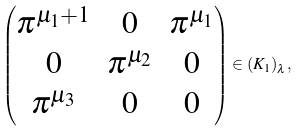Convert formula to latex. <formula><loc_0><loc_0><loc_500><loc_500>\begin{pmatrix} \pi ^ { \mu _ { 1 } + 1 } & 0 & \pi ^ { \mu _ { 1 } } \\ 0 & \pi ^ { \mu _ { 2 } } & 0 \\ \pi ^ { \mu _ { 3 } } & 0 & 0 \end{pmatrix} \in ( K _ { 1 } ) _ { \lambda } ,</formula> 